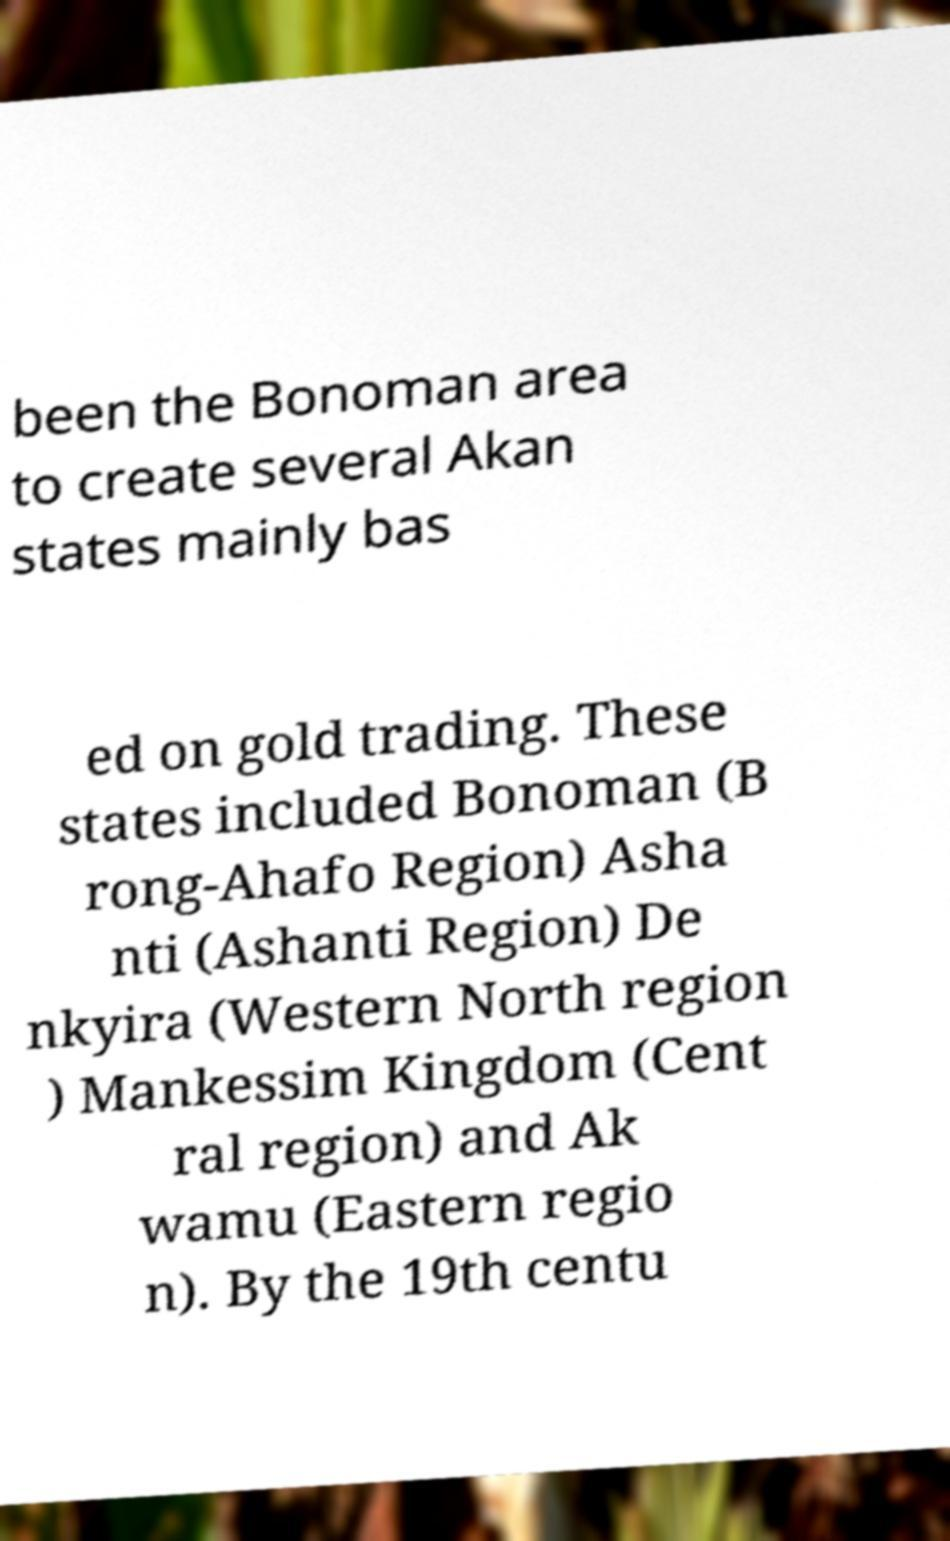Could you assist in decoding the text presented in this image and type it out clearly? been the Bonoman area to create several Akan states mainly bas ed on gold trading. These states included Bonoman (B rong-Ahafo Region) Asha nti (Ashanti Region) De nkyira (Western North region ) Mankessim Kingdom (Cent ral region) and Ak wamu (Eastern regio n). By the 19th centu 